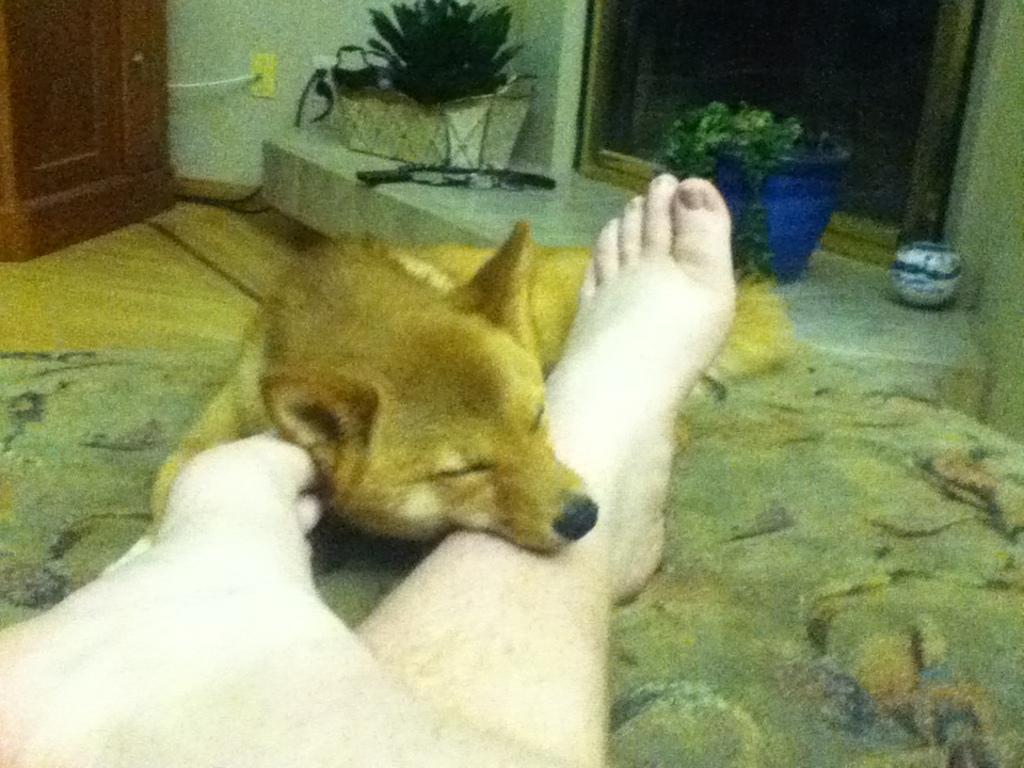Could you give a brief overview of what you see in this image? In this image we can see a dog, human legs, plants and door. 